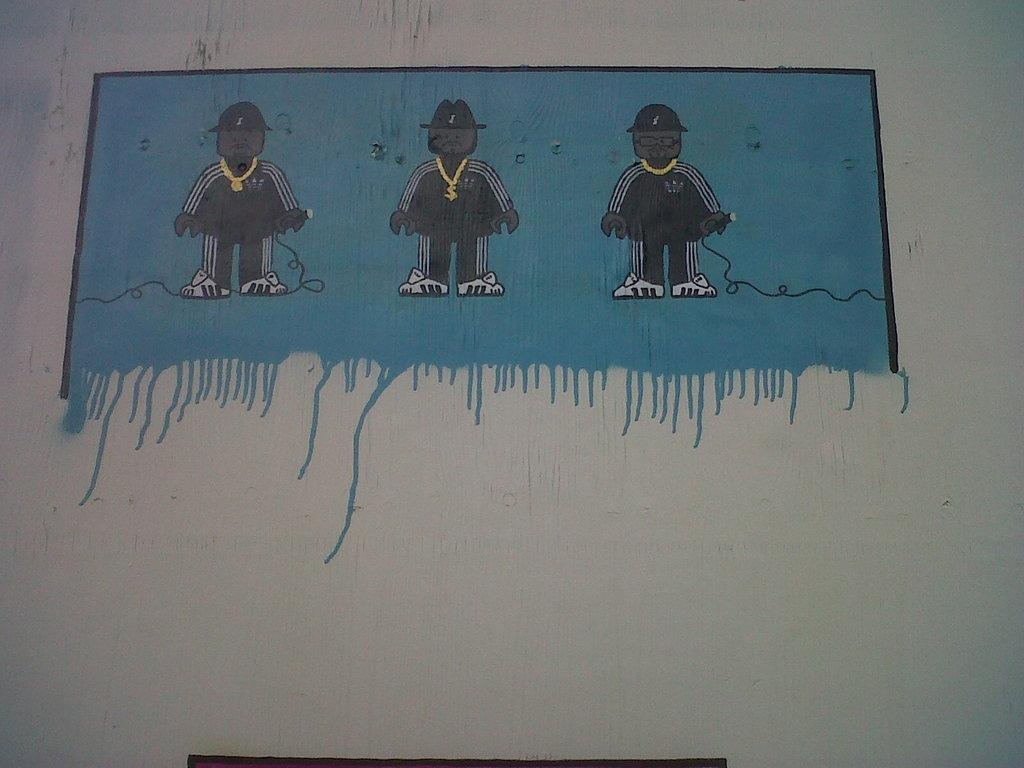What is the color of the surface in the image? The surface in the image is white. What is on the surface? There is a painting on the surface. What does the painting depict? The painting depicts three persons standing. What colors are used in the painting? The painting has black, white, and blue colors. How does the yak contribute to the industry in the image? There is no yak or reference to any industry in the image; it features a painting of three persons standing. 